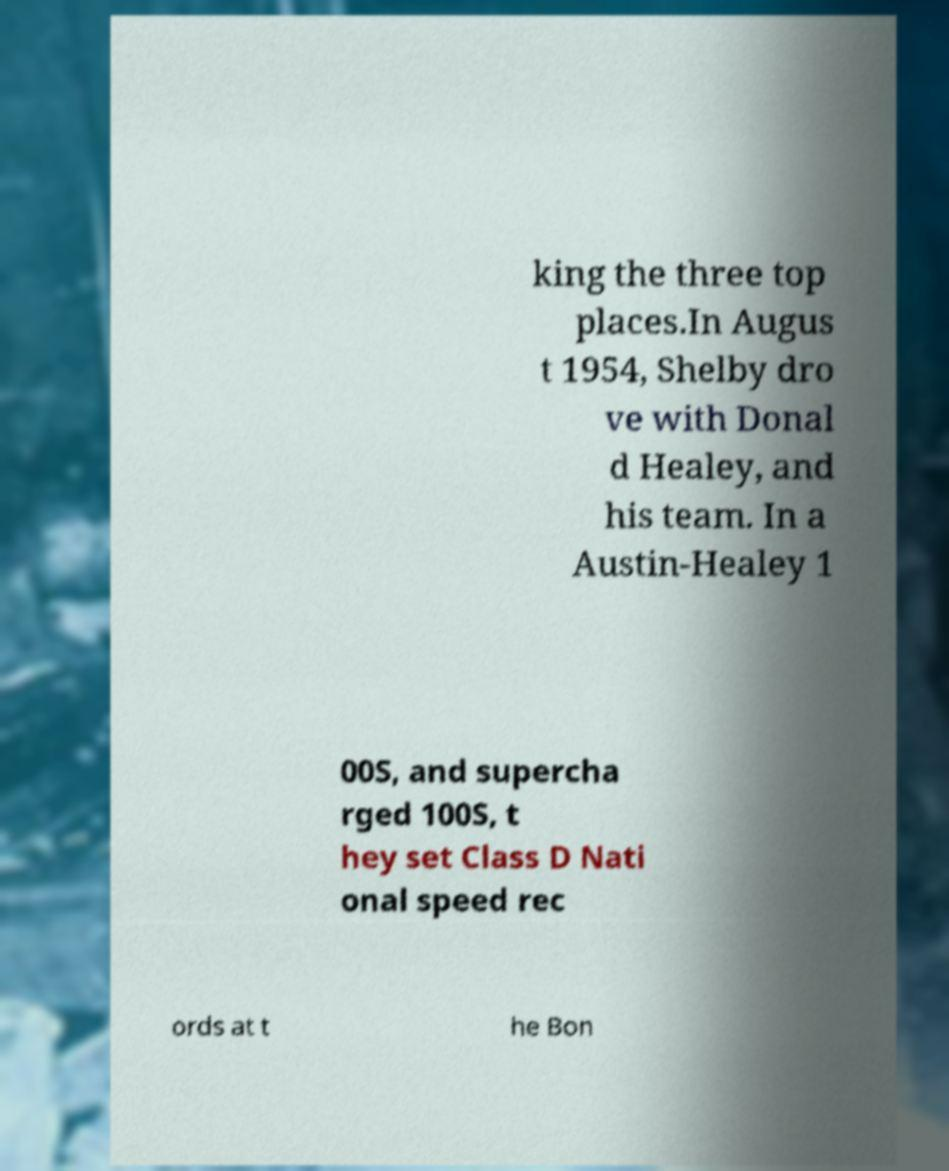Can you read and provide the text displayed in the image?This photo seems to have some interesting text. Can you extract and type it out for me? king the three top places.In Augus t 1954, Shelby dro ve with Donal d Healey, and his team. In a Austin-Healey 1 00S, and supercha rged 100S, t hey set Class D Nati onal speed rec ords at t he Bon 